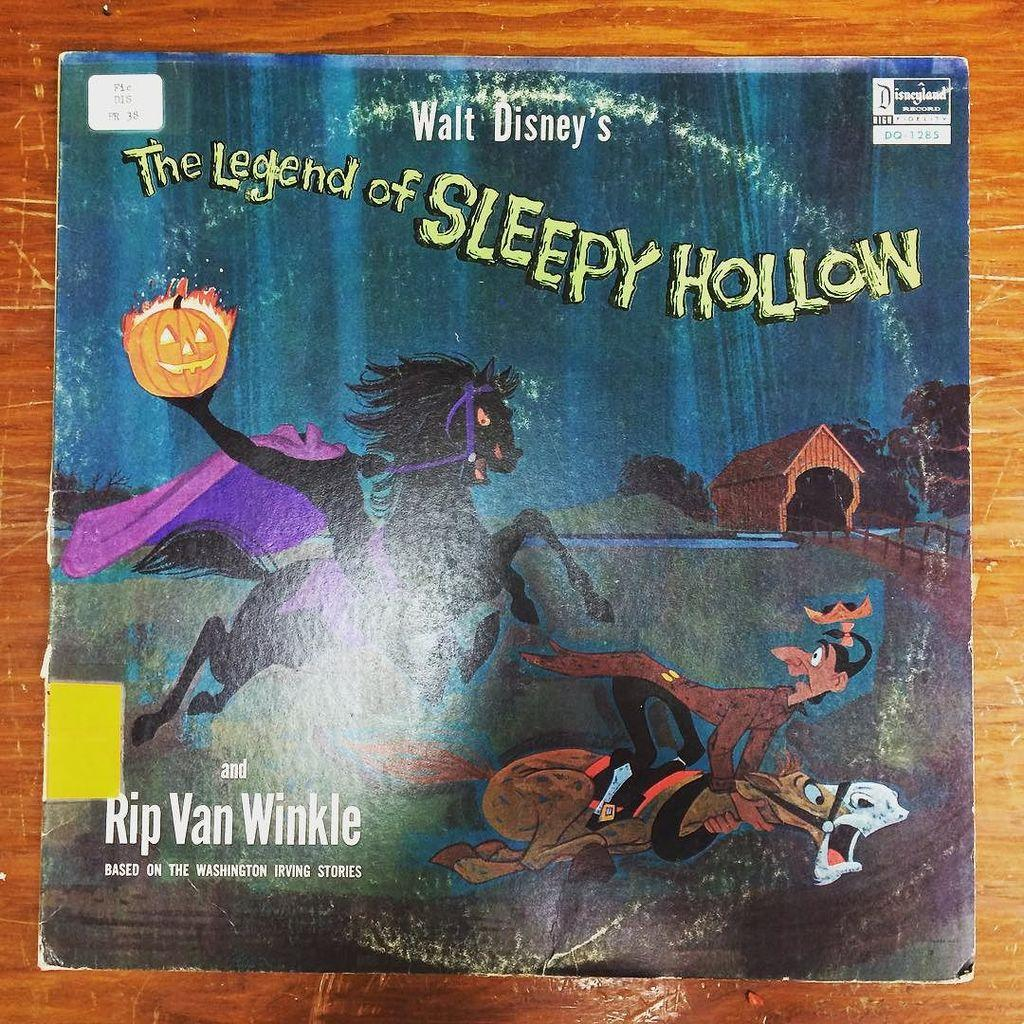<image>
Render a clear and concise summary of the photo. The legend of sleepy hollow lays on a wooden table 